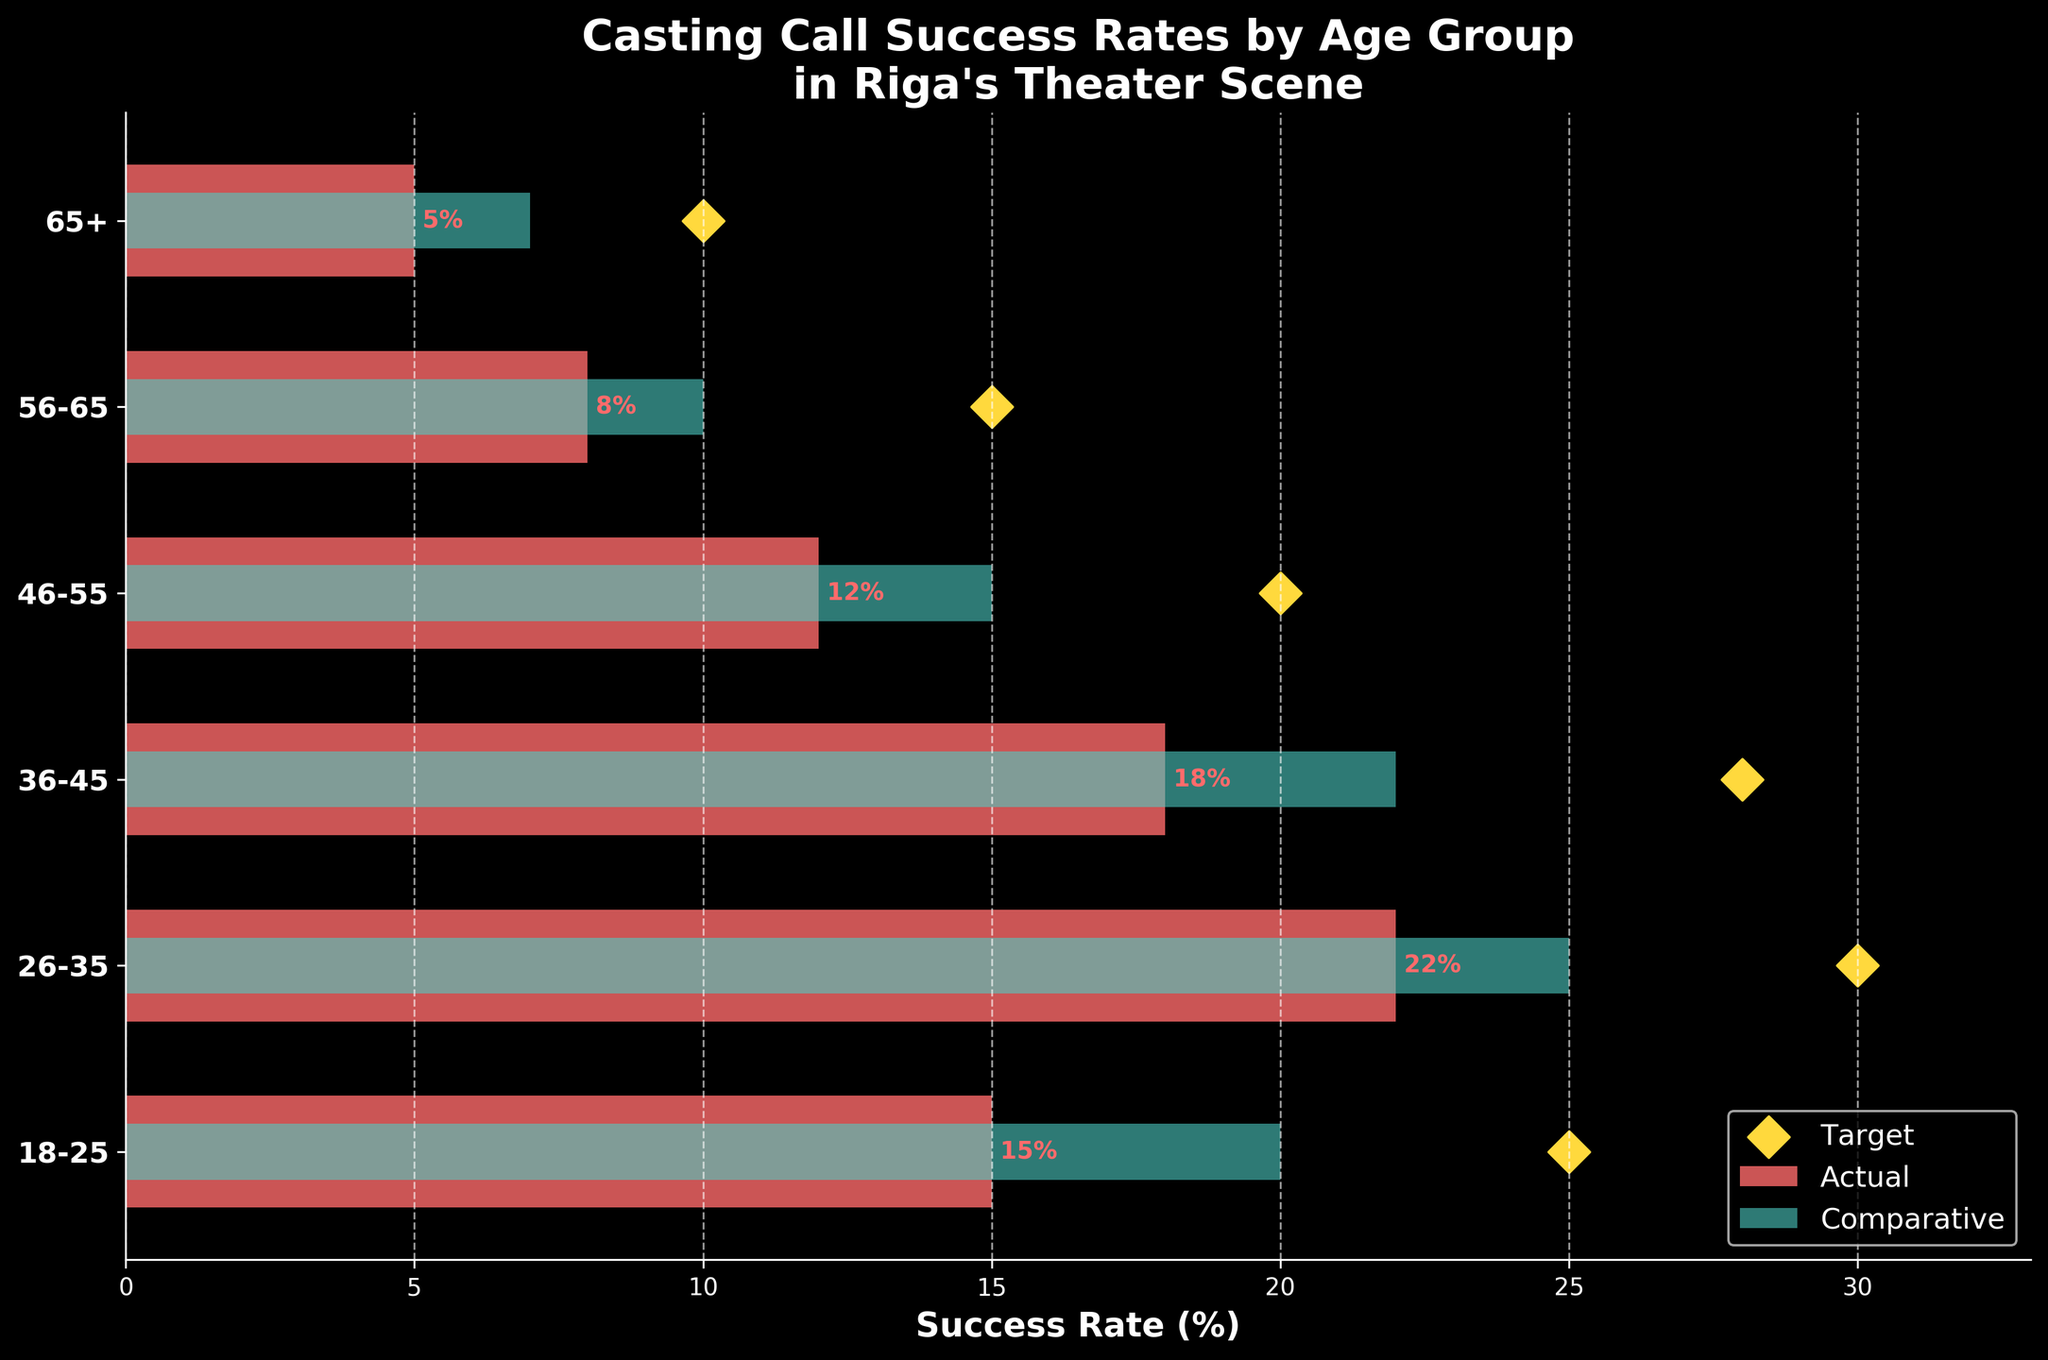What is the actual success rate for the 18-25 age group? Look at the bar representing the 18-25 age group and note the value of the Actual Success Rate.
Answer: 15% Which age group has the highest actual success rate? Compare the heights of the bars for the 'Actual Success Rate' among all age groups.
Answer: 26-35 What is the target success rate for the 56-65 age group? Identify the diamond marker representing the 'Target Success Rate' for the 56-65 age group.
Answer: 15% By how many percentage points does the actual success rate for the 36-45 age group fall short of its target success rate? Subtract the Actual Success Rate from the Target Success Rate for the 36-45 age group: 28 - 18.
Answer: 10% Compare the actual success rates of the 46-55 and 65+ age groups. Which one is higher? Examine the bars for the 46-55 and 65+ age groups and compare their 'Actual Success Rate' values.
Answer: 46-55 What is the average actual success rate across all age groups? Sum the Actual Success Rates for all age groups and divide by the number of age groups: (15 + 22 + 18 + 12 + 8 + 5) / 6.
Answer: 13.33% For which age group does the comparative success rate come closest to the target success rate? Compare the differences between the Comparative and Target Success Rates for each age group and identify the smallest difference.
Answer: 26-35 Which age group has the smallest actual success rate? Compare all the bars for Actual Success Rates and identify the smallest bar.
Answer: 65+ How much higher is the target success rate than the comparative success rate for the 26-35 age group? Subtract the Comparative Success Rate from the Target Success Rate for the 26-35 age group: 30 - 25.
Answer: 5% Is the actual success rate higher or lower than the comparative success rate for the 18-25 age group? Compare the heights of the bars representing the Actual and Comparative Success Rates for the 18-25 age group.
Answer: Lower 